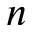<formula> <loc_0><loc_0><loc_500><loc_500>n</formula> 